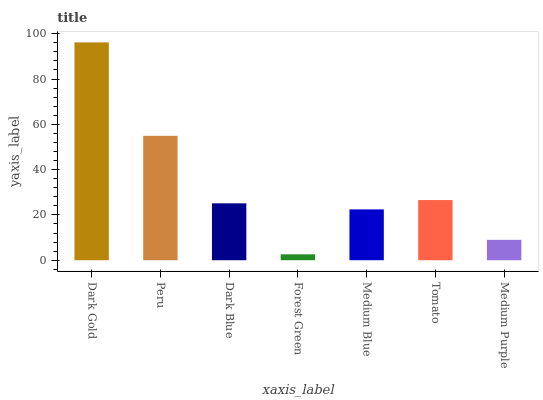Is Forest Green the minimum?
Answer yes or no. Yes. Is Dark Gold the maximum?
Answer yes or no. Yes. Is Peru the minimum?
Answer yes or no. No. Is Peru the maximum?
Answer yes or no. No. Is Dark Gold greater than Peru?
Answer yes or no. Yes. Is Peru less than Dark Gold?
Answer yes or no. Yes. Is Peru greater than Dark Gold?
Answer yes or no. No. Is Dark Gold less than Peru?
Answer yes or no. No. Is Dark Blue the high median?
Answer yes or no. Yes. Is Dark Blue the low median?
Answer yes or no. Yes. Is Medium Purple the high median?
Answer yes or no. No. Is Forest Green the low median?
Answer yes or no. No. 